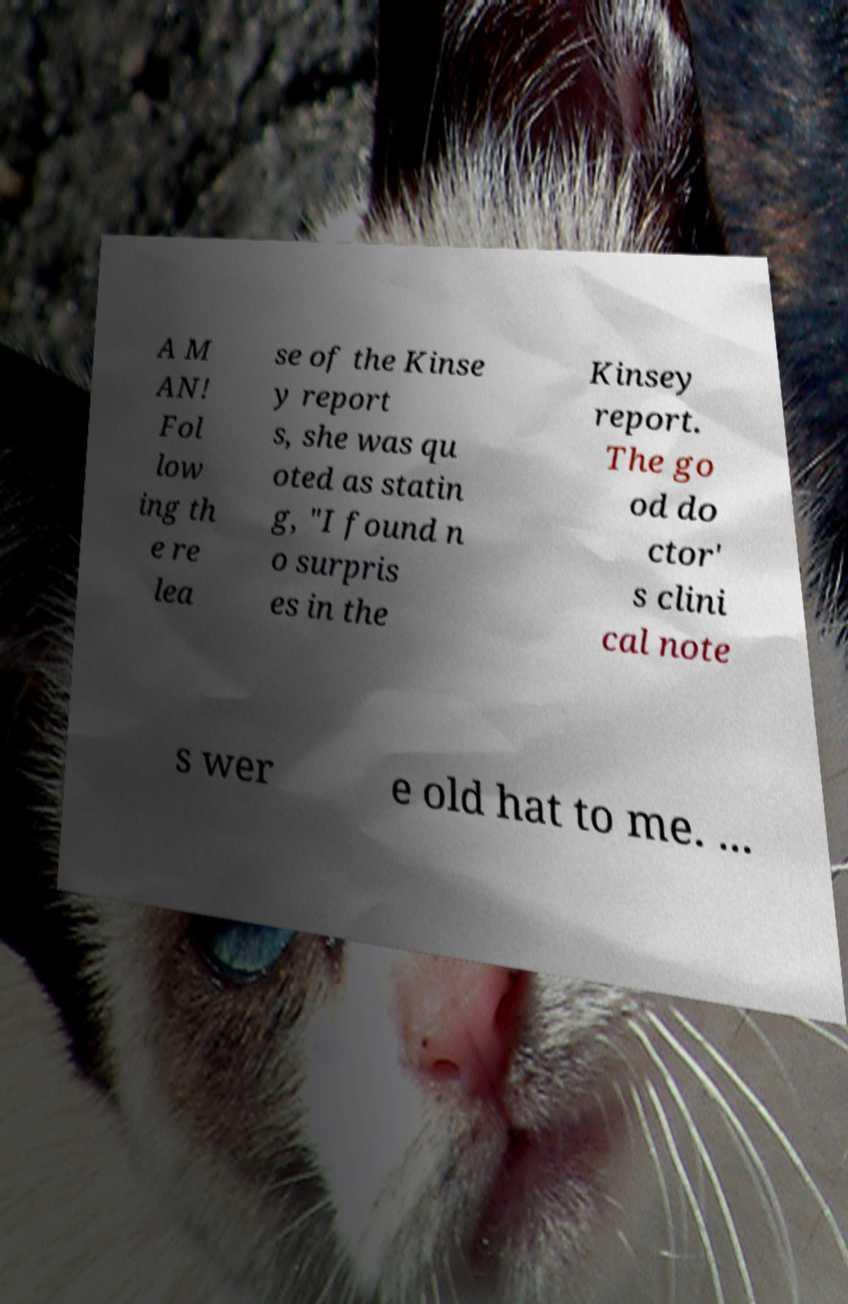Please read and relay the text visible in this image. What does it say? A M AN! Fol low ing th e re lea se of the Kinse y report s, she was qu oted as statin g, "I found n o surpris es in the Kinsey report. The go od do ctor' s clini cal note s wer e old hat to me. ... 